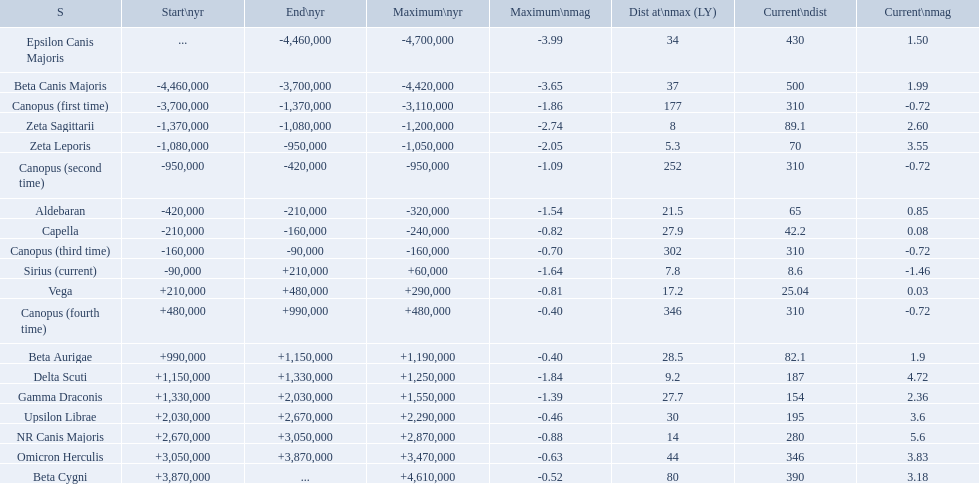What are all the stars? Epsilon Canis Majoris, Beta Canis Majoris, Canopus (first time), Zeta Sagittarii, Zeta Leporis, Canopus (second time), Aldebaran, Capella, Canopus (third time), Sirius (current), Vega, Canopus (fourth time), Beta Aurigae, Delta Scuti, Gamma Draconis, Upsilon Librae, NR Canis Majoris, Omicron Herculis, Beta Cygni. Of those, which star has a maximum distance of 80? Beta Cygni. 